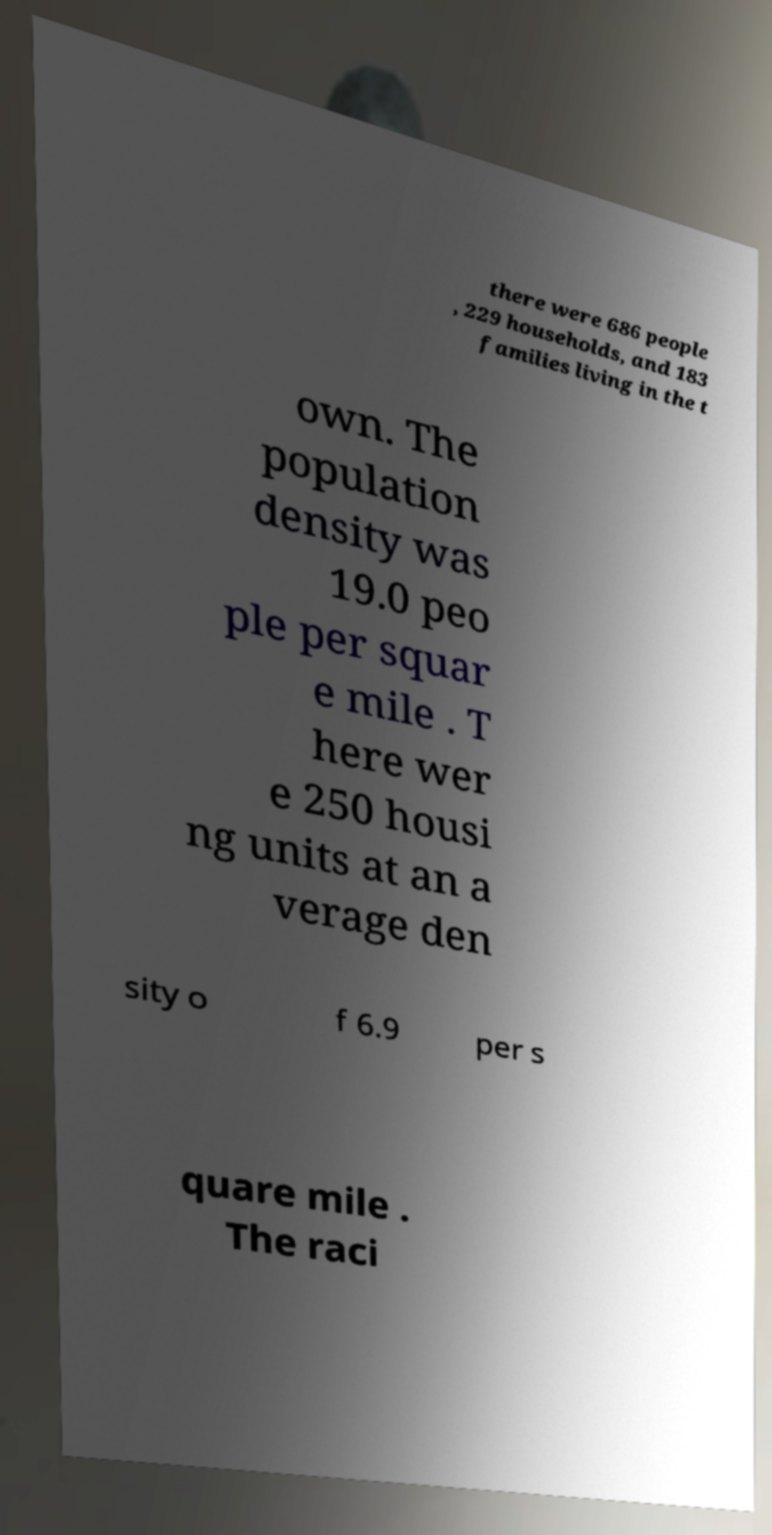Could you assist in decoding the text presented in this image and type it out clearly? there were 686 people , 229 households, and 183 families living in the t own. The population density was 19.0 peo ple per squar e mile . T here wer e 250 housi ng units at an a verage den sity o f 6.9 per s quare mile . The raci 